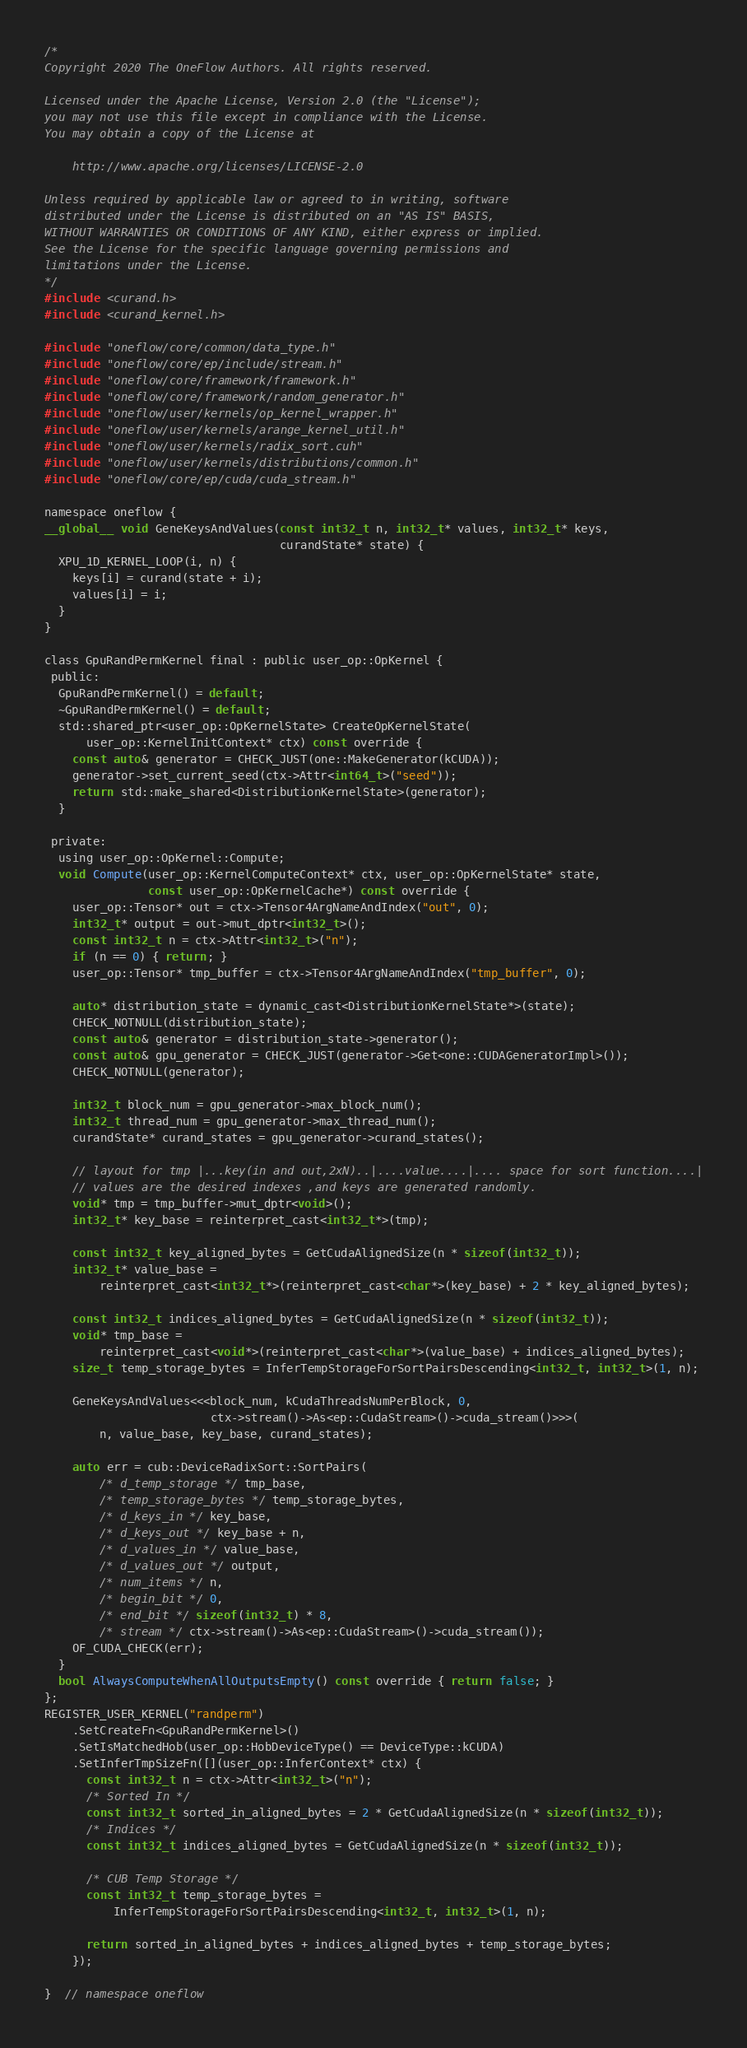Convert code to text. <code><loc_0><loc_0><loc_500><loc_500><_Cuda_>/*
Copyright 2020 The OneFlow Authors. All rights reserved.

Licensed under the Apache License, Version 2.0 (the "License");
you may not use this file except in compliance with the License.
You may obtain a copy of the License at

    http://www.apache.org/licenses/LICENSE-2.0

Unless required by applicable law or agreed to in writing, software
distributed under the License is distributed on an "AS IS" BASIS,
WITHOUT WARRANTIES OR CONDITIONS OF ANY KIND, either express or implied.
See the License for the specific language governing permissions and
limitations under the License.
*/
#include <curand.h>
#include <curand_kernel.h>

#include "oneflow/core/common/data_type.h"
#include "oneflow/core/ep/include/stream.h"
#include "oneflow/core/framework/framework.h"
#include "oneflow/core/framework/random_generator.h"
#include "oneflow/user/kernels/op_kernel_wrapper.h"
#include "oneflow/user/kernels/arange_kernel_util.h"
#include "oneflow/user/kernels/radix_sort.cuh"
#include "oneflow/user/kernels/distributions/common.h"
#include "oneflow/core/ep/cuda/cuda_stream.h"

namespace oneflow {
__global__ void GeneKeysAndValues(const int32_t n, int32_t* values, int32_t* keys,
                                  curandState* state) {
  XPU_1D_KERNEL_LOOP(i, n) {
    keys[i] = curand(state + i);
    values[i] = i;
  }
}

class GpuRandPermKernel final : public user_op::OpKernel {
 public:
  GpuRandPermKernel() = default;
  ~GpuRandPermKernel() = default;
  std::shared_ptr<user_op::OpKernelState> CreateOpKernelState(
      user_op::KernelInitContext* ctx) const override {
    const auto& generator = CHECK_JUST(one::MakeGenerator(kCUDA));
    generator->set_current_seed(ctx->Attr<int64_t>("seed"));
    return std::make_shared<DistributionKernelState>(generator);
  }

 private:
  using user_op::OpKernel::Compute;
  void Compute(user_op::KernelComputeContext* ctx, user_op::OpKernelState* state,
               const user_op::OpKernelCache*) const override {
    user_op::Tensor* out = ctx->Tensor4ArgNameAndIndex("out", 0);
    int32_t* output = out->mut_dptr<int32_t>();
    const int32_t n = ctx->Attr<int32_t>("n");
    if (n == 0) { return; }
    user_op::Tensor* tmp_buffer = ctx->Tensor4ArgNameAndIndex("tmp_buffer", 0);

    auto* distribution_state = dynamic_cast<DistributionKernelState*>(state);
    CHECK_NOTNULL(distribution_state);
    const auto& generator = distribution_state->generator();
    const auto& gpu_generator = CHECK_JUST(generator->Get<one::CUDAGeneratorImpl>());
    CHECK_NOTNULL(generator);

    int32_t block_num = gpu_generator->max_block_num();
    int32_t thread_num = gpu_generator->max_thread_num();
    curandState* curand_states = gpu_generator->curand_states();

    // layout for tmp |...key(in and out,2xN)..|....value....|.... space for sort function....|
    // values are the desired indexes ,and keys are generated randomly.
    void* tmp = tmp_buffer->mut_dptr<void>();
    int32_t* key_base = reinterpret_cast<int32_t*>(tmp);

    const int32_t key_aligned_bytes = GetCudaAlignedSize(n * sizeof(int32_t));
    int32_t* value_base =
        reinterpret_cast<int32_t*>(reinterpret_cast<char*>(key_base) + 2 * key_aligned_bytes);

    const int32_t indices_aligned_bytes = GetCudaAlignedSize(n * sizeof(int32_t));
    void* tmp_base =
        reinterpret_cast<void*>(reinterpret_cast<char*>(value_base) + indices_aligned_bytes);
    size_t temp_storage_bytes = InferTempStorageForSortPairsDescending<int32_t, int32_t>(1, n);

    GeneKeysAndValues<<<block_num, kCudaThreadsNumPerBlock, 0,
                        ctx->stream()->As<ep::CudaStream>()->cuda_stream()>>>(
        n, value_base, key_base, curand_states);

    auto err = cub::DeviceRadixSort::SortPairs(
        /* d_temp_storage */ tmp_base,
        /* temp_storage_bytes */ temp_storage_bytes,
        /* d_keys_in */ key_base,
        /* d_keys_out */ key_base + n,
        /* d_values_in */ value_base,
        /* d_values_out */ output,
        /* num_items */ n,
        /* begin_bit */ 0,
        /* end_bit */ sizeof(int32_t) * 8,
        /* stream */ ctx->stream()->As<ep::CudaStream>()->cuda_stream());
    OF_CUDA_CHECK(err);
  }
  bool AlwaysComputeWhenAllOutputsEmpty() const override { return false; }
};
REGISTER_USER_KERNEL("randperm")
    .SetCreateFn<GpuRandPermKernel>()
    .SetIsMatchedHob(user_op::HobDeviceType() == DeviceType::kCUDA)
    .SetInferTmpSizeFn([](user_op::InferContext* ctx) {
      const int32_t n = ctx->Attr<int32_t>("n");
      /* Sorted In */
      const int32_t sorted_in_aligned_bytes = 2 * GetCudaAlignedSize(n * sizeof(int32_t));
      /* Indices */
      const int32_t indices_aligned_bytes = GetCudaAlignedSize(n * sizeof(int32_t));

      /* CUB Temp Storage */
      const int32_t temp_storage_bytes =
          InferTempStorageForSortPairsDescending<int32_t, int32_t>(1, n);

      return sorted_in_aligned_bytes + indices_aligned_bytes + temp_storage_bytes;
    });

}  // namespace oneflow
</code> 